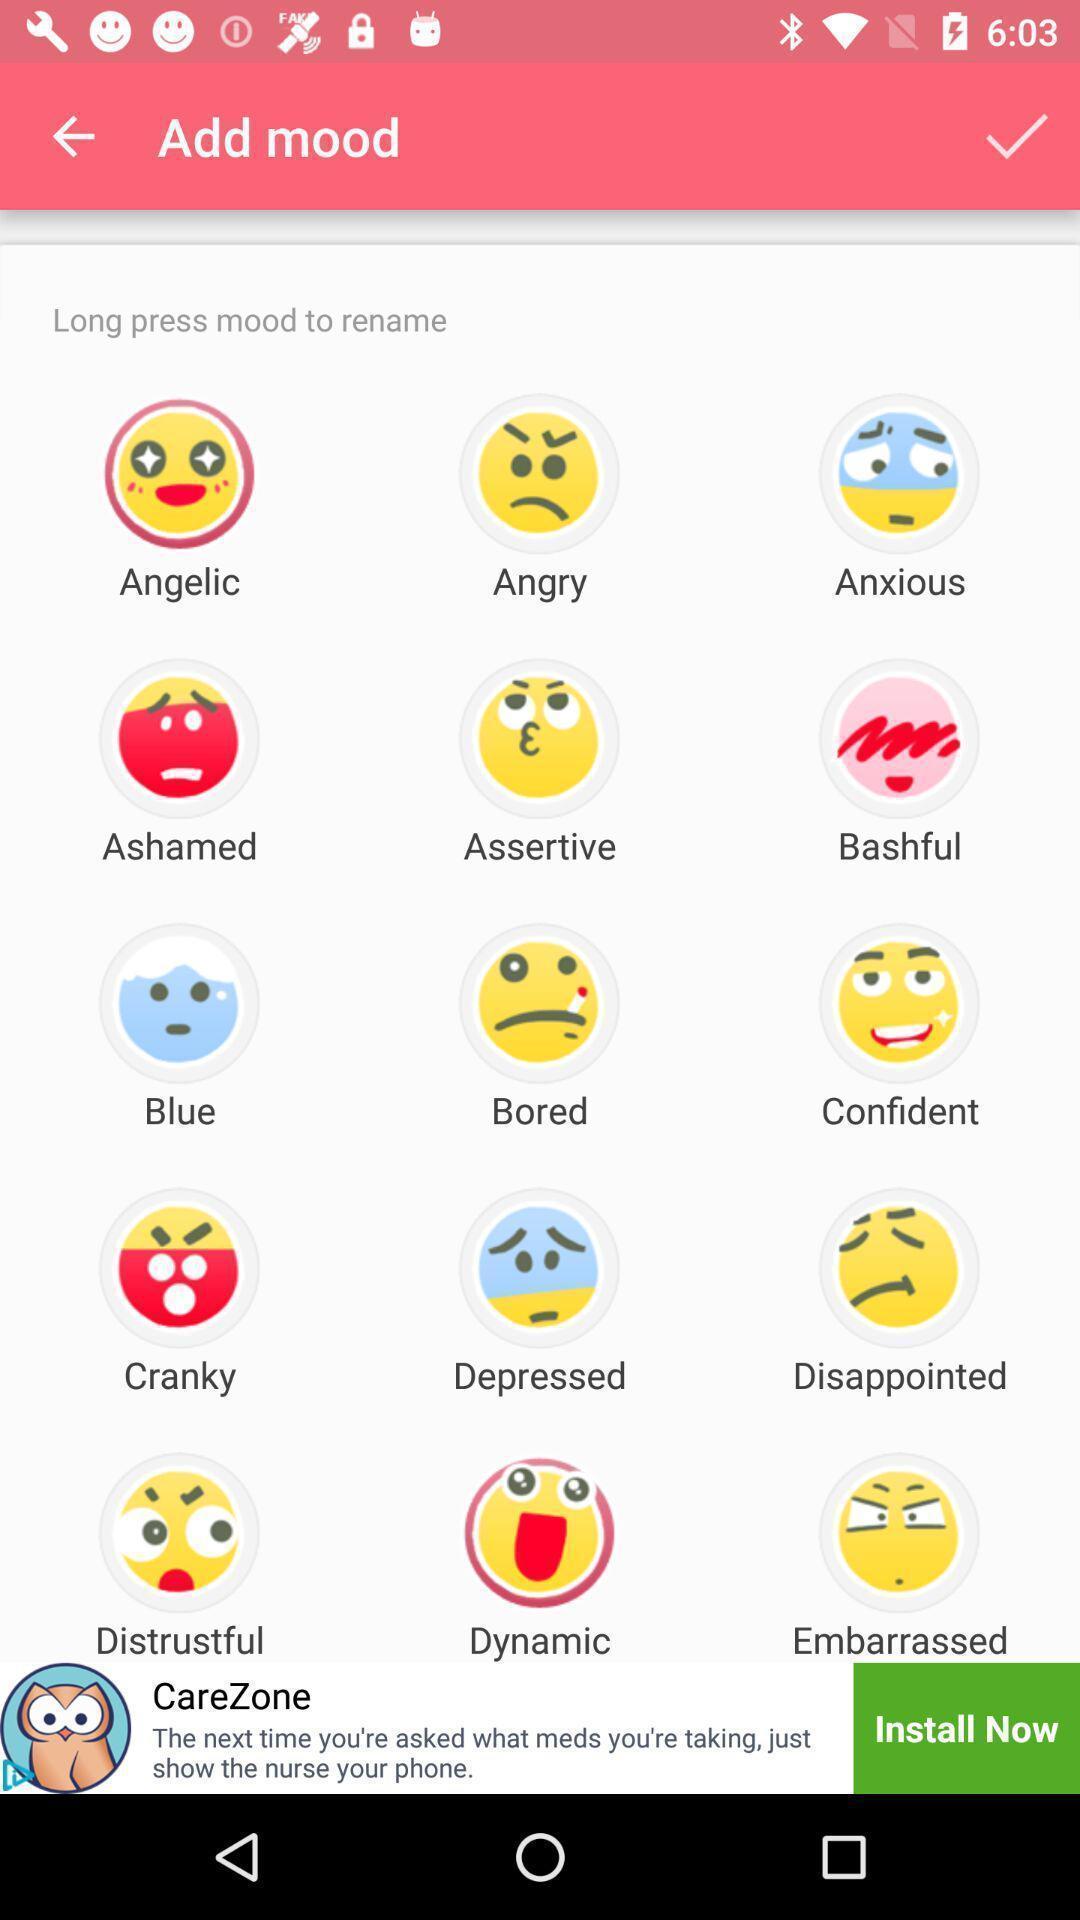What details can you identify in this image? Screen displaying different emojis. 